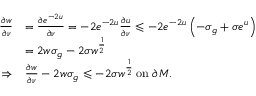<formula> <loc_0><loc_0><loc_500><loc_500>\begin{array} { r l } { \frac { \partial w } { \partial \nu } } & { = \frac { \partial e ^ { - 2 u } } { \partial \nu } = - 2 e ^ { - 2 u } \frac { \partial u } { \partial \nu } \leqslant - 2 e ^ { - 2 u } \left ( - \sigma _ { g } + \sigma e ^ { u } \right ) } \\ & { = 2 w \sigma _ { g } - 2 \sigma w ^ { \frac { 1 } { 2 } } } \\ { \Rightarrow } & { \frac { \partial w } { \partial \nu } - 2 w \sigma _ { g } \leqslant - 2 \sigma w ^ { \frac { 1 } { 2 } } \, o n \, \partial M . } \end{array}</formula> 